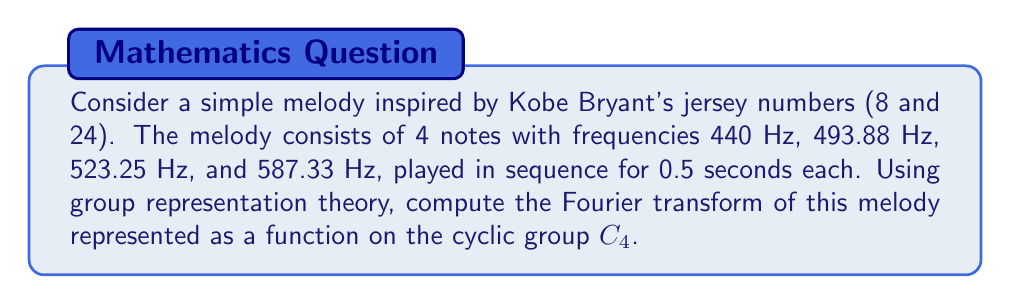Teach me how to tackle this problem. Let's approach this step-by-step:

1) First, we need to represent our melody as a function on the cyclic group $C_4$. Let $f: C_4 \rightarrow \mathbb{C}$ be defined as:

   $f(0) = 440$, $f(1) = 493.88$, $f(2) = 523.25$, $f(3) = 587.33$

2) The irreducible representations of $C_4$ are given by:

   $\rho_k(j) = e^{2\pi i kj/4}$, where $k = 0, 1, 2, 3$

3) The Fourier transform $\hat{f}(k)$ is given by:

   $$\hat{f}(k) = \frac{1}{|G|} \sum_{j \in G} f(j) \overline{\rho_k(j)}$$

   where $|G| = 4$ is the order of the group.

4) Let's compute each $\hat{f}(k)$:

   $$\begin{align*}
   \hat{f}(0) &= \frac{1}{4}(440 + 493.88 + 523.25 + 587.33) = 511.115 \\
   \hat{f}(1) &= \frac{1}{4}(440 + 493.88i - 523.25 - 587.33i) = -20.8125 - 23.3625i \\
   \hat{f}(2) &= \frac{1}{4}(440 - 493.88 + 523.25 - 587.33) = -29.49 \\
   \hat{f}(3) &= \frac{1}{4}(440 - 493.88i - 523.25 + 587.33i) = -20.8125 + 23.3625i
   \end{align*}$$

5) These values represent the amplitudes of the frequency components in the melody, corresponding to 0 Hz, 0.5 Hz, 1 Hz, and 1.5 Hz respectively (given the 2-second total duration).
Answer: $\hat{f}(0) = 511.115$, $\hat{f}(1) = -20.8125 - 23.3625i$, $\hat{f}(2) = -29.49$, $\hat{f}(3) = -20.8125 + 23.3625i$ 